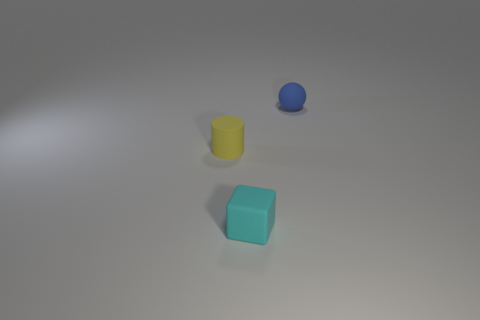Add 2 large blue rubber balls. How many objects exist? 5 Subtract all cylinders. How many objects are left? 2 Subtract all rubber objects. Subtract all brown rubber blocks. How many objects are left? 0 Add 3 small yellow rubber objects. How many small yellow rubber objects are left? 4 Add 2 blue things. How many blue things exist? 3 Subtract 0 red cylinders. How many objects are left? 3 